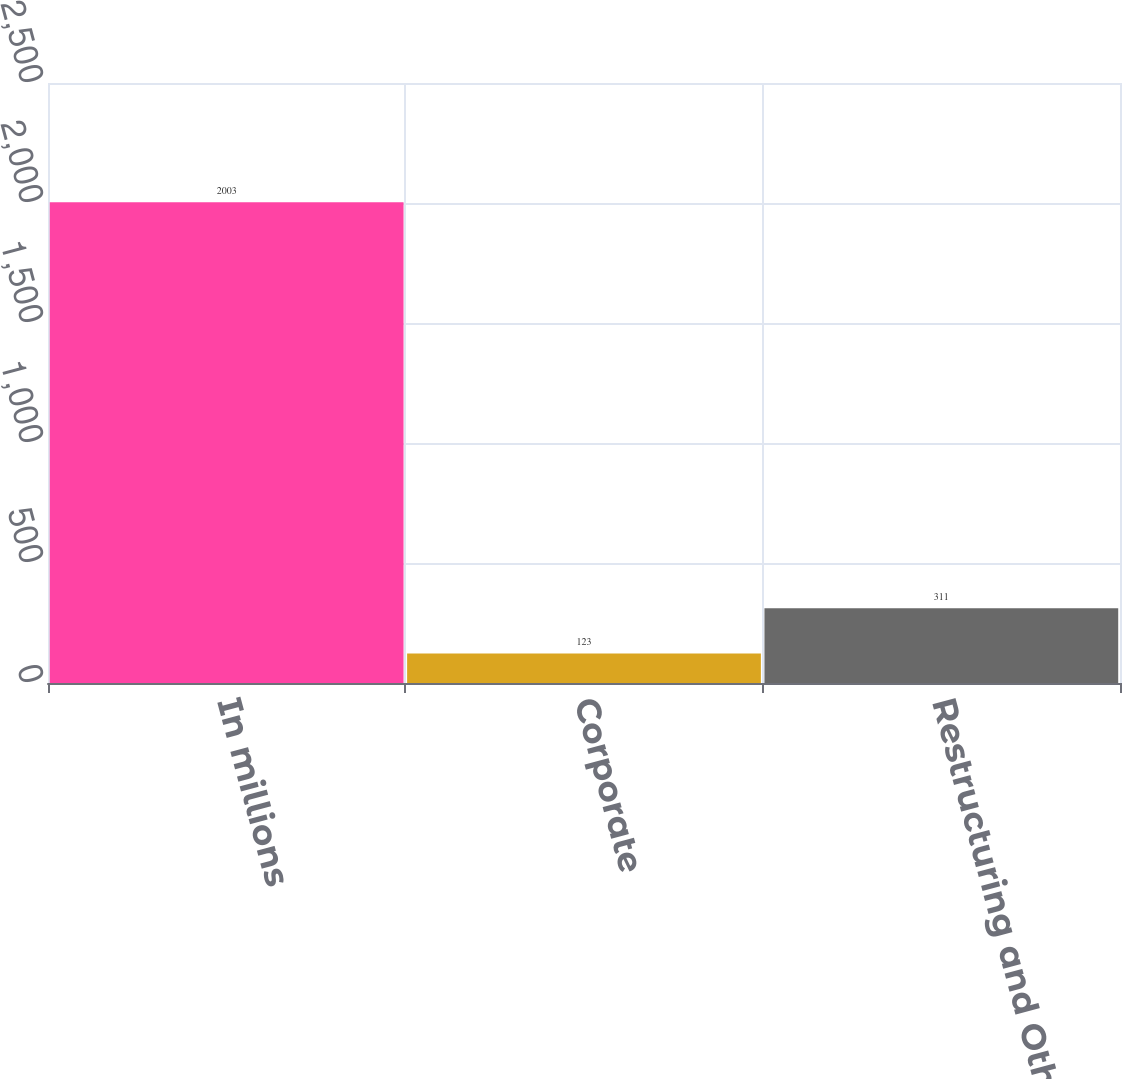<chart> <loc_0><loc_0><loc_500><loc_500><bar_chart><fcel>In millions<fcel>Corporate<fcel>Restructuring and Other<nl><fcel>2003<fcel>123<fcel>311<nl></chart> 